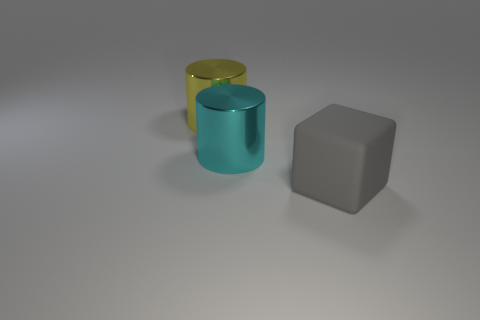Add 2 red rubber objects. How many objects exist? 5 Subtract all cylinders. How many objects are left? 1 Subtract 2 cylinders. How many cylinders are left? 0 Subtract all red cylinders. Subtract all cyan balls. How many cylinders are left? 2 Subtract all tiny brown matte objects. Subtract all gray cubes. How many objects are left? 2 Add 2 gray blocks. How many gray blocks are left? 3 Add 1 yellow cylinders. How many yellow cylinders exist? 2 Subtract 0 brown cubes. How many objects are left? 3 